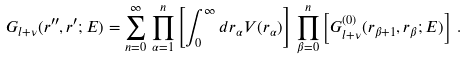Convert formula to latex. <formula><loc_0><loc_0><loc_500><loc_500>G _ { l + \nu } ( r ^ { \prime \prime } , r ^ { \prime } ; E ) = \sum _ { n = 0 } ^ { \infty } \, \prod _ { \alpha = 1 } ^ { n } \left [ \int _ { 0 } ^ { \infty } d r _ { \alpha } V ( r _ { \alpha } ) \right ] \, \prod _ { \beta = 0 } ^ { n } \left [ G ^ { ( 0 ) } _ { l + \nu } ( r _ { \beta + 1 } , r _ { \beta } ; E ) \right ] \, .</formula> 